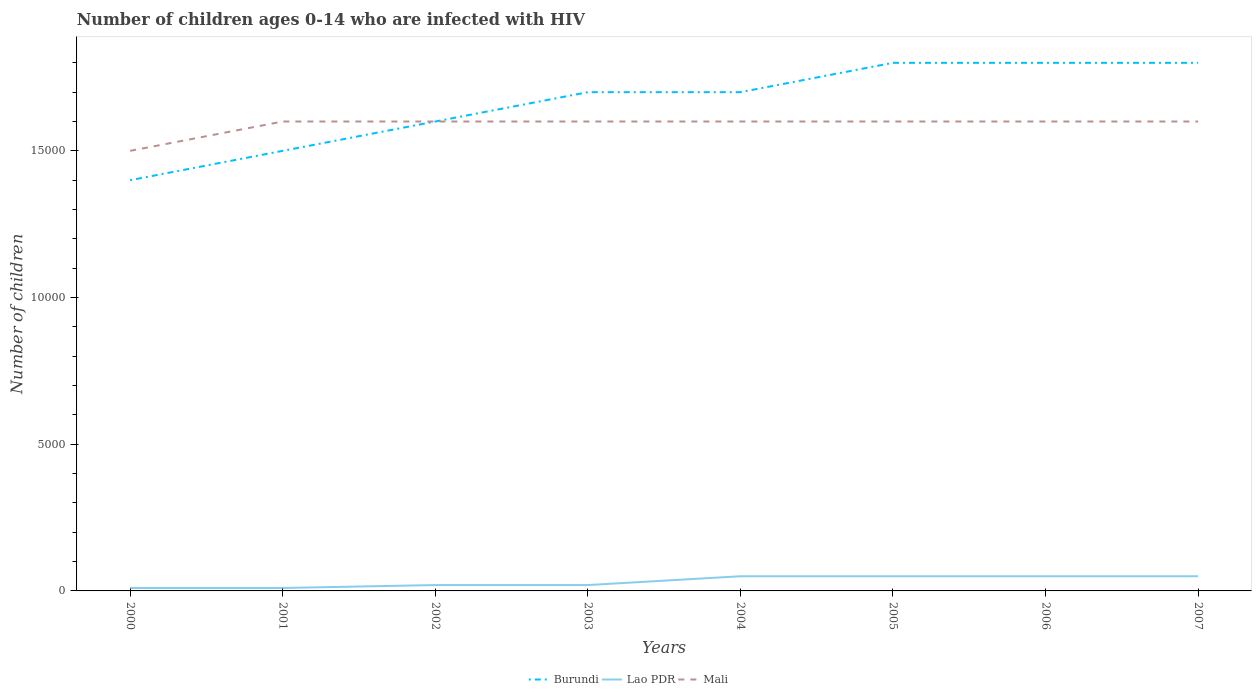Does the line corresponding to Lao PDR intersect with the line corresponding to Mali?
Offer a terse response. No. Across all years, what is the maximum number of HIV infected children in Mali?
Offer a terse response. 1.50e+04. In which year was the number of HIV infected children in Burundi maximum?
Ensure brevity in your answer.  2000. What is the difference between the highest and the second highest number of HIV infected children in Burundi?
Your answer should be compact. 4000. What is the difference between the highest and the lowest number of HIV infected children in Mali?
Make the answer very short. 7. Is the number of HIV infected children in Burundi strictly greater than the number of HIV infected children in Mali over the years?
Provide a short and direct response. No. How many years are there in the graph?
Ensure brevity in your answer.  8. Where does the legend appear in the graph?
Offer a very short reply. Bottom center. How are the legend labels stacked?
Provide a short and direct response. Horizontal. What is the title of the graph?
Provide a succinct answer. Number of children ages 0-14 who are infected with HIV. Does "Kyrgyz Republic" appear as one of the legend labels in the graph?
Offer a terse response. No. What is the label or title of the Y-axis?
Make the answer very short. Number of children. What is the Number of children of Burundi in 2000?
Offer a terse response. 1.40e+04. What is the Number of children in Lao PDR in 2000?
Keep it short and to the point. 100. What is the Number of children in Mali in 2000?
Your response must be concise. 1.50e+04. What is the Number of children in Burundi in 2001?
Provide a short and direct response. 1.50e+04. What is the Number of children in Mali in 2001?
Provide a succinct answer. 1.60e+04. What is the Number of children in Burundi in 2002?
Offer a terse response. 1.60e+04. What is the Number of children of Mali in 2002?
Your answer should be very brief. 1.60e+04. What is the Number of children in Burundi in 2003?
Give a very brief answer. 1.70e+04. What is the Number of children of Lao PDR in 2003?
Offer a very short reply. 200. What is the Number of children of Mali in 2003?
Offer a terse response. 1.60e+04. What is the Number of children in Burundi in 2004?
Your response must be concise. 1.70e+04. What is the Number of children of Lao PDR in 2004?
Your answer should be compact. 500. What is the Number of children of Mali in 2004?
Keep it short and to the point. 1.60e+04. What is the Number of children of Burundi in 2005?
Provide a succinct answer. 1.80e+04. What is the Number of children of Lao PDR in 2005?
Offer a very short reply. 500. What is the Number of children of Mali in 2005?
Provide a succinct answer. 1.60e+04. What is the Number of children in Burundi in 2006?
Your answer should be compact. 1.80e+04. What is the Number of children of Lao PDR in 2006?
Give a very brief answer. 500. What is the Number of children of Mali in 2006?
Keep it short and to the point. 1.60e+04. What is the Number of children of Burundi in 2007?
Offer a very short reply. 1.80e+04. What is the Number of children in Lao PDR in 2007?
Your response must be concise. 500. What is the Number of children in Mali in 2007?
Your answer should be very brief. 1.60e+04. Across all years, what is the maximum Number of children in Burundi?
Provide a succinct answer. 1.80e+04. Across all years, what is the maximum Number of children of Lao PDR?
Your response must be concise. 500. Across all years, what is the maximum Number of children of Mali?
Make the answer very short. 1.60e+04. Across all years, what is the minimum Number of children of Burundi?
Your response must be concise. 1.40e+04. Across all years, what is the minimum Number of children of Mali?
Your answer should be compact. 1.50e+04. What is the total Number of children of Burundi in the graph?
Your answer should be compact. 1.33e+05. What is the total Number of children in Lao PDR in the graph?
Offer a terse response. 2600. What is the total Number of children in Mali in the graph?
Make the answer very short. 1.27e+05. What is the difference between the Number of children of Burundi in 2000 and that in 2001?
Keep it short and to the point. -1000. What is the difference between the Number of children of Lao PDR in 2000 and that in 2001?
Your answer should be very brief. 0. What is the difference between the Number of children of Mali in 2000 and that in 2001?
Offer a very short reply. -1000. What is the difference between the Number of children of Burundi in 2000 and that in 2002?
Offer a terse response. -2000. What is the difference between the Number of children in Lao PDR in 2000 and that in 2002?
Give a very brief answer. -100. What is the difference between the Number of children of Mali in 2000 and that in 2002?
Your answer should be very brief. -1000. What is the difference between the Number of children in Burundi in 2000 and that in 2003?
Your answer should be very brief. -3000. What is the difference between the Number of children in Lao PDR in 2000 and that in 2003?
Your response must be concise. -100. What is the difference between the Number of children of Mali in 2000 and that in 2003?
Offer a terse response. -1000. What is the difference between the Number of children of Burundi in 2000 and that in 2004?
Ensure brevity in your answer.  -3000. What is the difference between the Number of children of Lao PDR in 2000 and that in 2004?
Offer a terse response. -400. What is the difference between the Number of children in Mali in 2000 and that in 2004?
Ensure brevity in your answer.  -1000. What is the difference between the Number of children of Burundi in 2000 and that in 2005?
Keep it short and to the point. -4000. What is the difference between the Number of children in Lao PDR in 2000 and that in 2005?
Provide a short and direct response. -400. What is the difference between the Number of children in Mali in 2000 and that in 2005?
Ensure brevity in your answer.  -1000. What is the difference between the Number of children of Burundi in 2000 and that in 2006?
Provide a succinct answer. -4000. What is the difference between the Number of children in Lao PDR in 2000 and that in 2006?
Provide a short and direct response. -400. What is the difference between the Number of children in Mali in 2000 and that in 2006?
Keep it short and to the point. -1000. What is the difference between the Number of children in Burundi in 2000 and that in 2007?
Offer a very short reply. -4000. What is the difference between the Number of children of Lao PDR in 2000 and that in 2007?
Your answer should be compact. -400. What is the difference between the Number of children in Mali in 2000 and that in 2007?
Give a very brief answer. -1000. What is the difference between the Number of children in Burundi in 2001 and that in 2002?
Your answer should be very brief. -1000. What is the difference between the Number of children in Lao PDR in 2001 and that in 2002?
Provide a succinct answer. -100. What is the difference between the Number of children of Mali in 2001 and that in 2002?
Keep it short and to the point. 0. What is the difference between the Number of children of Burundi in 2001 and that in 2003?
Provide a succinct answer. -2000. What is the difference between the Number of children of Lao PDR in 2001 and that in 2003?
Make the answer very short. -100. What is the difference between the Number of children in Mali in 2001 and that in 2003?
Your answer should be very brief. 0. What is the difference between the Number of children in Burundi in 2001 and that in 2004?
Give a very brief answer. -2000. What is the difference between the Number of children of Lao PDR in 2001 and that in 2004?
Your answer should be very brief. -400. What is the difference between the Number of children of Mali in 2001 and that in 2004?
Provide a succinct answer. 0. What is the difference between the Number of children of Burundi in 2001 and that in 2005?
Your response must be concise. -3000. What is the difference between the Number of children of Lao PDR in 2001 and that in 2005?
Your answer should be compact. -400. What is the difference between the Number of children of Mali in 2001 and that in 2005?
Offer a terse response. 0. What is the difference between the Number of children of Burundi in 2001 and that in 2006?
Provide a short and direct response. -3000. What is the difference between the Number of children in Lao PDR in 2001 and that in 2006?
Ensure brevity in your answer.  -400. What is the difference between the Number of children in Burundi in 2001 and that in 2007?
Make the answer very short. -3000. What is the difference between the Number of children of Lao PDR in 2001 and that in 2007?
Provide a short and direct response. -400. What is the difference between the Number of children of Burundi in 2002 and that in 2003?
Give a very brief answer. -1000. What is the difference between the Number of children in Lao PDR in 2002 and that in 2003?
Offer a very short reply. 0. What is the difference between the Number of children of Burundi in 2002 and that in 2004?
Offer a terse response. -1000. What is the difference between the Number of children of Lao PDR in 2002 and that in 2004?
Keep it short and to the point. -300. What is the difference between the Number of children of Burundi in 2002 and that in 2005?
Your response must be concise. -2000. What is the difference between the Number of children in Lao PDR in 2002 and that in 2005?
Provide a short and direct response. -300. What is the difference between the Number of children in Burundi in 2002 and that in 2006?
Give a very brief answer. -2000. What is the difference between the Number of children in Lao PDR in 2002 and that in 2006?
Ensure brevity in your answer.  -300. What is the difference between the Number of children of Burundi in 2002 and that in 2007?
Make the answer very short. -2000. What is the difference between the Number of children of Lao PDR in 2002 and that in 2007?
Provide a succinct answer. -300. What is the difference between the Number of children in Mali in 2002 and that in 2007?
Offer a very short reply. 0. What is the difference between the Number of children of Burundi in 2003 and that in 2004?
Provide a succinct answer. 0. What is the difference between the Number of children of Lao PDR in 2003 and that in 2004?
Keep it short and to the point. -300. What is the difference between the Number of children of Mali in 2003 and that in 2004?
Your answer should be compact. 0. What is the difference between the Number of children in Burundi in 2003 and that in 2005?
Your answer should be very brief. -1000. What is the difference between the Number of children in Lao PDR in 2003 and that in 2005?
Give a very brief answer. -300. What is the difference between the Number of children in Mali in 2003 and that in 2005?
Your answer should be compact. 0. What is the difference between the Number of children in Burundi in 2003 and that in 2006?
Provide a short and direct response. -1000. What is the difference between the Number of children in Lao PDR in 2003 and that in 2006?
Your answer should be very brief. -300. What is the difference between the Number of children in Burundi in 2003 and that in 2007?
Offer a very short reply. -1000. What is the difference between the Number of children in Lao PDR in 2003 and that in 2007?
Your response must be concise. -300. What is the difference between the Number of children of Mali in 2003 and that in 2007?
Your answer should be compact. 0. What is the difference between the Number of children of Burundi in 2004 and that in 2005?
Your response must be concise. -1000. What is the difference between the Number of children in Lao PDR in 2004 and that in 2005?
Provide a succinct answer. 0. What is the difference between the Number of children in Burundi in 2004 and that in 2006?
Your response must be concise. -1000. What is the difference between the Number of children of Mali in 2004 and that in 2006?
Provide a short and direct response. 0. What is the difference between the Number of children of Burundi in 2004 and that in 2007?
Provide a succinct answer. -1000. What is the difference between the Number of children in Lao PDR in 2004 and that in 2007?
Your response must be concise. 0. What is the difference between the Number of children of Mali in 2004 and that in 2007?
Make the answer very short. 0. What is the difference between the Number of children in Burundi in 2005 and that in 2006?
Your response must be concise. 0. What is the difference between the Number of children of Lao PDR in 2005 and that in 2006?
Provide a short and direct response. 0. What is the difference between the Number of children of Mali in 2005 and that in 2006?
Ensure brevity in your answer.  0. What is the difference between the Number of children in Mali in 2005 and that in 2007?
Your answer should be compact. 0. What is the difference between the Number of children of Burundi in 2006 and that in 2007?
Offer a very short reply. 0. What is the difference between the Number of children in Lao PDR in 2006 and that in 2007?
Ensure brevity in your answer.  0. What is the difference between the Number of children in Burundi in 2000 and the Number of children in Lao PDR in 2001?
Keep it short and to the point. 1.39e+04. What is the difference between the Number of children of Burundi in 2000 and the Number of children of Mali in 2001?
Keep it short and to the point. -2000. What is the difference between the Number of children in Lao PDR in 2000 and the Number of children in Mali in 2001?
Ensure brevity in your answer.  -1.59e+04. What is the difference between the Number of children in Burundi in 2000 and the Number of children in Lao PDR in 2002?
Your answer should be very brief. 1.38e+04. What is the difference between the Number of children in Burundi in 2000 and the Number of children in Mali in 2002?
Keep it short and to the point. -2000. What is the difference between the Number of children of Lao PDR in 2000 and the Number of children of Mali in 2002?
Offer a very short reply. -1.59e+04. What is the difference between the Number of children of Burundi in 2000 and the Number of children of Lao PDR in 2003?
Offer a very short reply. 1.38e+04. What is the difference between the Number of children of Burundi in 2000 and the Number of children of Mali in 2003?
Ensure brevity in your answer.  -2000. What is the difference between the Number of children of Lao PDR in 2000 and the Number of children of Mali in 2003?
Your answer should be compact. -1.59e+04. What is the difference between the Number of children in Burundi in 2000 and the Number of children in Lao PDR in 2004?
Provide a short and direct response. 1.35e+04. What is the difference between the Number of children in Burundi in 2000 and the Number of children in Mali in 2004?
Your response must be concise. -2000. What is the difference between the Number of children of Lao PDR in 2000 and the Number of children of Mali in 2004?
Make the answer very short. -1.59e+04. What is the difference between the Number of children in Burundi in 2000 and the Number of children in Lao PDR in 2005?
Offer a very short reply. 1.35e+04. What is the difference between the Number of children of Burundi in 2000 and the Number of children of Mali in 2005?
Give a very brief answer. -2000. What is the difference between the Number of children in Lao PDR in 2000 and the Number of children in Mali in 2005?
Offer a terse response. -1.59e+04. What is the difference between the Number of children of Burundi in 2000 and the Number of children of Lao PDR in 2006?
Offer a very short reply. 1.35e+04. What is the difference between the Number of children of Burundi in 2000 and the Number of children of Mali in 2006?
Provide a short and direct response. -2000. What is the difference between the Number of children of Lao PDR in 2000 and the Number of children of Mali in 2006?
Offer a very short reply. -1.59e+04. What is the difference between the Number of children of Burundi in 2000 and the Number of children of Lao PDR in 2007?
Offer a terse response. 1.35e+04. What is the difference between the Number of children of Burundi in 2000 and the Number of children of Mali in 2007?
Offer a very short reply. -2000. What is the difference between the Number of children in Lao PDR in 2000 and the Number of children in Mali in 2007?
Keep it short and to the point. -1.59e+04. What is the difference between the Number of children in Burundi in 2001 and the Number of children in Lao PDR in 2002?
Offer a very short reply. 1.48e+04. What is the difference between the Number of children of Burundi in 2001 and the Number of children of Mali in 2002?
Make the answer very short. -1000. What is the difference between the Number of children of Lao PDR in 2001 and the Number of children of Mali in 2002?
Your answer should be compact. -1.59e+04. What is the difference between the Number of children of Burundi in 2001 and the Number of children of Lao PDR in 2003?
Provide a succinct answer. 1.48e+04. What is the difference between the Number of children in Burundi in 2001 and the Number of children in Mali in 2003?
Provide a short and direct response. -1000. What is the difference between the Number of children in Lao PDR in 2001 and the Number of children in Mali in 2003?
Ensure brevity in your answer.  -1.59e+04. What is the difference between the Number of children in Burundi in 2001 and the Number of children in Lao PDR in 2004?
Provide a succinct answer. 1.45e+04. What is the difference between the Number of children of Burundi in 2001 and the Number of children of Mali in 2004?
Provide a succinct answer. -1000. What is the difference between the Number of children of Lao PDR in 2001 and the Number of children of Mali in 2004?
Offer a terse response. -1.59e+04. What is the difference between the Number of children of Burundi in 2001 and the Number of children of Lao PDR in 2005?
Provide a succinct answer. 1.45e+04. What is the difference between the Number of children in Burundi in 2001 and the Number of children in Mali in 2005?
Your answer should be compact. -1000. What is the difference between the Number of children in Lao PDR in 2001 and the Number of children in Mali in 2005?
Offer a very short reply. -1.59e+04. What is the difference between the Number of children of Burundi in 2001 and the Number of children of Lao PDR in 2006?
Your answer should be very brief. 1.45e+04. What is the difference between the Number of children of Burundi in 2001 and the Number of children of Mali in 2006?
Your response must be concise. -1000. What is the difference between the Number of children of Lao PDR in 2001 and the Number of children of Mali in 2006?
Keep it short and to the point. -1.59e+04. What is the difference between the Number of children in Burundi in 2001 and the Number of children in Lao PDR in 2007?
Offer a very short reply. 1.45e+04. What is the difference between the Number of children of Burundi in 2001 and the Number of children of Mali in 2007?
Make the answer very short. -1000. What is the difference between the Number of children of Lao PDR in 2001 and the Number of children of Mali in 2007?
Keep it short and to the point. -1.59e+04. What is the difference between the Number of children of Burundi in 2002 and the Number of children of Lao PDR in 2003?
Ensure brevity in your answer.  1.58e+04. What is the difference between the Number of children of Burundi in 2002 and the Number of children of Mali in 2003?
Provide a succinct answer. 0. What is the difference between the Number of children in Lao PDR in 2002 and the Number of children in Mali in 2003?
Provide a succinct answer. -1.58e+04. What is the difference between the Number of children of Burundi in 2002 and the Number of children of Lao PDR in 2004?
Give a very brief answer. 1.55e+04. What is the difference between the Number of children of Burundi in 2002 and the Number of children of Mali in 2004?
Provide a succinct answer. 0. What is the difference between the Number of children in Lao PDR in 2002 and the Number of children in Mali in 2004?
Keep it short and to the point. -1.58e+04. What is the difference between the Number of children of Burundi in 2002 and the Number of children of Lao PDR in 2005?
Make the answer very short. 1.55e+04. What is the difference between the Number of children in Lao PDR in 2002 and the Number of children in Mali in 2005?
Provide a short and direct response. -1.58e+04. What is the difference between the Number of children of Burundi in 2002 and the Number of children of Lao PDR in 2006?
Your answer should be very brief. 1.55e+04. What is the difference between the Number of children in Burundi in 2002 and the Number of children in Mali in 2006?
Your response must be concise. 0. What is the difference between the Number of children of Lao PDR in 2002 and the Number of children of Mali in 2006?
Offer a very short reply. -1.58e+04. What is the difference between the Number of children in Burundi in 2002 and the Number of children in Lao PDR in 2007?
Provide a succinct answer. 1.55e+04. What is the difference between the Number of children in Lao PDR in 2002 and the Number of children in Mali in 2007?
Give a very brief answer. -1.58e+04. What is the difference between the Number of children of Burundi in 2003 and the Number of children of Lao PDR in 2004?
Offer a terse response. 1.65e+04. What is the difference between the Number of children of Lao PDR in 2003 and the Number of children of Mali in 2004?
Provide a short and direct response. -1.58e+04. What is the difference between the Number of children in Burundi in 2003 and the Number of children in Lao PDR in 2005?
Keep it short and to the point. 1.65e+04. What is the difference between the Number of children in Lao PDR in 2003 and the Number of children in Mali in 2005?
Ensure brevity in your answer.  -1.58e+04. What is the difference between the Number of children in Burundi in 2003 and the Number of children in Lao PDR in 2006?
Ensure brevity in your answer.  1.65e+04. What is the difference between the Number of children in Lao PDR in 2003 and the Number of children in Mali in 2006?
Offer a terse response. -1.58e+04. What is the difference between the Number of children of Burundi in 2003 and the Number of children of Lao PDR in 2007?
Ensure brevity in your answer.  1.65e+04. What is the difference between the Number of children in Burundi in 2003 and the Number of children in Mali in 2007?
Your answer should be compact. 1000. What is the difference between the Number of children of Lao PDR in 2003 and the Number of children of Mali in 2007?
Keep it short and to the point. -1.58e+04. What is the difference between the Number of children of Burundi in 2004 and the Number of children of Lao PDR in 2005?
Provide a short and direct response. 1.65e+04. What is the difference between the Number of children in Burundi in 2004 and the Number of children in Mali in 2005?
Your answer should be compact. 1000. What is the difference between the Number of children in Lao PDR in 2004 and the Number of children in Mali in 2005?
Keep it short and to the point. -1.55e+04. What is the difference between the Number of children in Burundi in 2004 and the Number of children in Lao PDR in 2006?
Offer a very short reply. 1.65e+04. What is the difference between the Number of children of Burundi in 2004 and the Number of children of Mali in 2006?
Provide a short and direct response. 1000. What is the difference between the Number of children in Lao PDR in 2004 and the Number of children in Mali in 2006?
Give a very brief answer. -1.55e+04. What is the difference between the Number of children of Burundi in 2004 and the Number of children of Lao PDR in 2007?
Offer a very short reply. 1.65e+04. What is the difference between the Number of children in Burundi in 2004 and the Number of children in Mali in 2007?
Make the answer very short. 1000. What is the difference between the Number of children of Lao PDR in 2004 and the Number of children of Mali in 2007?
Provide a succinct answer. -1.55e+04. What is the difference between the Number of children in Burundi in 2005 and the Number of children in Lao PDR in 2006?
Your answer should be compact. 1.75e+04. What is the difference between the Number of children of Lao PDR in 2005 and the Number of children of Mali in 2006?
Your answer should be very brief. -1.55e+04. What is the difference between the Number of children in Burundi in 2005 and the Number of children in Lao PDR in 2007?
Offer a very short reply. 1.75e+04. What is the difference between the Number of children in Burundi in 2005 and the Number of children in Mali in 2007?
Give a very brief answer. 2000. What is the difference between the Number of children of Lao PDR in 2005 and the Number of children of Mali in 2007?
Give a very brief answer. -1.55e+04. What is the difference between the Number of children in Burundi in 2006 and the Number of children in Lao PDR in 2007?
Ensure brevity in your answer.  1.75e+04. What is the difference between the Number of children in Burundi in 2006 and the Number of children in Mali in 2007?
Provide a short and direct response. 2000. What is the difference between the Number of children in Lao PDR in 2006 and the Number of children in Mali in 2007?
Provide a succinct answer. -1.55e+04. What is the average Number of children in Burundi per year?
Provide a short and direct response. 1.66e+04. What is the average Number of children in Lao PDR per year?
Provide a succinct answer. 325. What is the average Number of children of Mali per year?
Make the answer very short. 1.59e+04. In the year 2000, what is the difference between the Number of children in Burundi and Number of children in Lao PDR?
Offer a very short reply. 1.39e+04. In the year 2000, what is the difference between the Number of children of Burundi and Number of children of Mali?
Offer a terse response. -1000. In the year 2000, what is the difference between the Number of children in Lao PDR and Number of children in Mali?
Offer a very short reply. -1.49e+04. In the year 2001, what is the difference between the Number of children in Burundi and Number of children in Lao PDR?
Provide a succinct answer. 1.49e+04. In the year 2001, what is the difference between the Number of children of Burundi and Number of children of Mali?
Offer a terse response. -1000. In the year 2001, what is the difference between the Number of children of Lao PDR and Number of children of Mali?
Provide a succinct answer. -1.59e+04. In the year 2002, what is the difference between the Number of children of Burundi and Number of children of Lao PDR?
Your response must be concise. 1.58e+04. In the year 2002, what is the difference between the Number of children of Lao PDR and Number of children of Mali?
Provide a succinct answer. -1.58e+04. In the year 2003, what is the difference between the Number of children in Burundi and Number of children in Lao PDR?
Make the answer very short. 1.68e+04. In the year 2003, what is the difference between the Number of children of Lao PDR and Number of children of Mali?
Keep it short and to the point. -1.58e+04. In the year 2004, what is the difference between the Number of children in Burundi and Number of children in Lao PDR?
Make the answer very short. 1.65e+04. In the year 2004, what is the difference between the Number of children of Burundi and Number of children of Mali?
Your response must be concise. 1000. In the year 2004, what is the difference between the Number of children of Lao PDR and Number of children of Mali?
Your answer should be very brief. -1.55e+04. In the year 2005, what is the difference between the Number of children of Burundi and Number of children of Lao PDR?
Provide a succinct answer. 1.75e+04. In the year 2005, what is the difference between the Number of children of Lao PDR and Number of children of Mali?
Make the answer very short. -1.55e+04. In the year 2006, what is the difference between the Number of children in Burundi and Number of children in Lao PDR?
Provide a succinct answer. 1.75e+04. In the year 2006, what is the difference between the Number of children in Burundi and Number of children in Mali?
Your answer should be very brief. 2000. In the year 2006, what is the difference between the Number of children in Lao PDR and Number of children in Mali?
Provide a short and direct response. -1.55e+04. In the year 2007, what is the difference between the Number of children of Burundi and Number of children of Lao PDR?
Your response must be concise. 1.75e+04. In the year 2007, what is the difference between the Number of children in Burundi and Number of children in Mali?
Your response must be concise. 2000. In the year 2007, what is the difference between the Number of children of Lao PDR and Number of children of Mali?
Give a very brief answer. -1.55e+04. What is the ratio of the Number of children of Lao PDR in 2000 to that in 2001?
Provide a succinct answer. 1. What is the ratio of the Number of children of Lao PDR in 2000 to that in 2002?
Keep it short and to the point. 0.5. What is the ratio of the Number of children in Mali in 2000 to that in 2002?
Your answer should be very brief. 0.94. What is the ratio of the Number of children of Burundi in 2000 to that in 2003?
Your answer should be very brief. 0.82. What is the ratio of the Number of children in Burundi in 2000 to that in 2004?
Provide a succinct answer. 0.82. What is the ratio of the Number of children of Lao PDR in 2000 to that in 2004?
Give a very brief answer. 0.2. What is the ratio of the Number of children in Mali in 2000 to that in 2004?
Keep it short and to the point. 0.94. What is the ratio of the Number of children of Burundi in 2000 to that in 2005?
Offer a terse response. 0.78. What is the ratio of the Number of children of Lao PDR in 2000 to that in 2005?
Offer a very short reply. 0.2. What is the ratio of the Number of children of Mali in 2000 to that in 2005?
Your answer should be compact. 0.94. What is the ratio of the Number of children in Burundi in 2000 to that in 2007?
Keep it short and to the point. 0.78. What is the ratio of the Number of children of Lao PDR in 2000 to that in 2007?
Your response must be concise. 0.2. What is the ratio of the Number of children in Burundi in 2001 to that in 2003?
Ensure brevity in your answer.  0.88. What is the ratio of the Number of children in Lao PDR in 2001 to that in 2003?
Your response must be concise. 0.5. What is the ratio of the Number of children in Burundi in 2001 to that in 2004?
Provide a short and direct response. 0.88. What is the ratio of the Number of children of Lao PDR in 2001 to that in 2004?
Offer a very short reply. 0.2. What is the ratio of the Number of children of Burundi in 2001 to that in 2005?
Your answer should be compact. 0.83. What is the ratio of the Number of children in Burundi in 2001 to that in 2006?
Make the answer very short. 0.83. What is the ratio of the Number of children in Lao PDR in 2001 to that in 2006?
Keep it short and to the point. 0.2. What is the ratio of the Number of children of Lao PDR in 2001 to that in 2007?
Keep it short and to the point. 0.2. What is the ratio of the Number of children in Mali in 2001 to that in 2007?
Make the answer very short. 1. What is the ratio of the Number of children of Burundi in 2002 to that in 2003?
Provide a short and direct response. 0.94. What is the ratio of the Number of children of Mali in 2002 to that in 2003?
Offer a terse response. 1. What is the ratio of the Number of children in Burundi in 2002 to that in 2004?
Give a very brief answer. 0.94. What is the ratio of the Number of children of Lao PDR in 2002 to that in 2004?
Provide a short and direct response. 0.4. What is the ratio of the Number of children of Lao PDR in 2002 to that in 2006?
Give a very brief answer. 0.4. What is the ratio of the Number of children in Mali in 2002 to that in 2006?
Provide a short and direct response. 1. What is the ratio of the Number of children of Mali in 2002 to that in 2007?
Offer a terse response. 1. What is the ratio of the Number of children of Burundi in 2003 to that in 2004?
Ensure brevity in your answer.  1. What is the ratio of the Number of children of Mali in 2003 to that in 2004?
Offer a terse response. 1. What is the ratio of the Number of children in Burundi in 2003 to that in 2005?
Your response must be concise. 0.94. What is the ratio of the Number of children of Mali in 2003 to that in 2005?
Give a very brief answer. 1. What is the ratio of the Number of children in Burundi in 2003 to that in 2006?
Your answer should be compact. 0.94. What is the ratio of the Number of children of Lao PDR in 2003 to that in 2006?
Provide a succinct answer. 0.4. What is the ratio of the Number of children in Mali in 2003 to that in 2006?
Offer a very short reply. 1. What is the ratio of the Number of children in Mali in 2003 to that in 2007?
Provide a succinct answer. 1. What is the ratio of the Number of children in Burundi in 2004 to that in 2006?
Provide a short and direct response. 0.94. What is the ratio of the Number of children in Lao PDR in 2005 to that in 2007?
Your answer should be very brief. 1. What is the ratio of the Number of children of Burundi in 2006 to that in 2007?
Offer a terse response. 1. What is the ratio of the Number of children of Mali in 2006 to that in 2007?
Give a very brief answer. 1. What is the difference between the highest and the second highest Number of children in Lao PDR?
Keep it short and to the point. 0. What is the difference between the highest and the lowest Number of children in Burundi?
Your answer should be very brief. 4000. What is the difference between the highest and the lowest Number of children in Lao PDR?
Your answer should be very brief. 400. What is the difference between the highest and the lowest Number of children in Mali?
Give a very brief answer. 1000. 